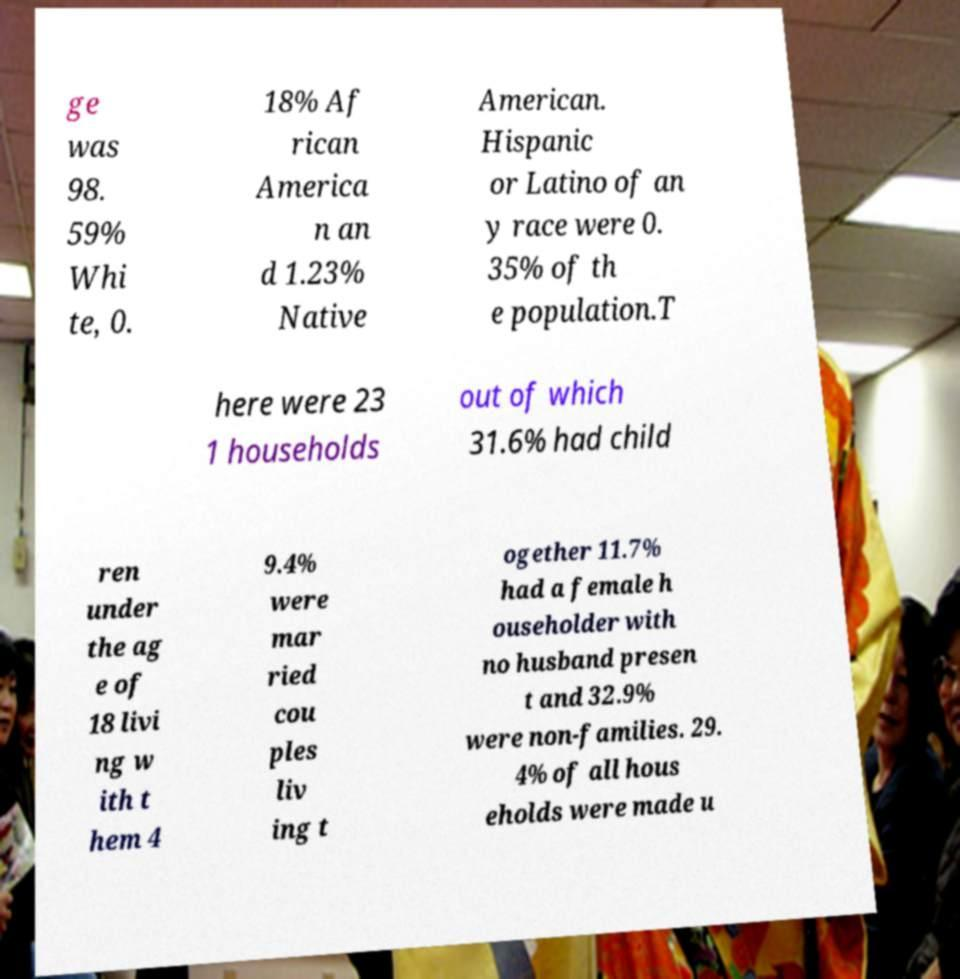I need the written content from this picture converted into text. Can you do that? ge was 98. 59% Whi te, 0. 18% Af rican America n an d 1.23% Native American. Hispanic or Latino of an y race were 0. 35% of th e population.T here were 23 1 households out of which 31.6% had child ren under the ag e of 18 livi ng w ith t hem 4 9.4% were mar ried cou ples liv ing t ogether 11.7% had a female h ouseholder with no husband presen t and 32.9% were non-families. 29. 4% of all hous eholds were made u 